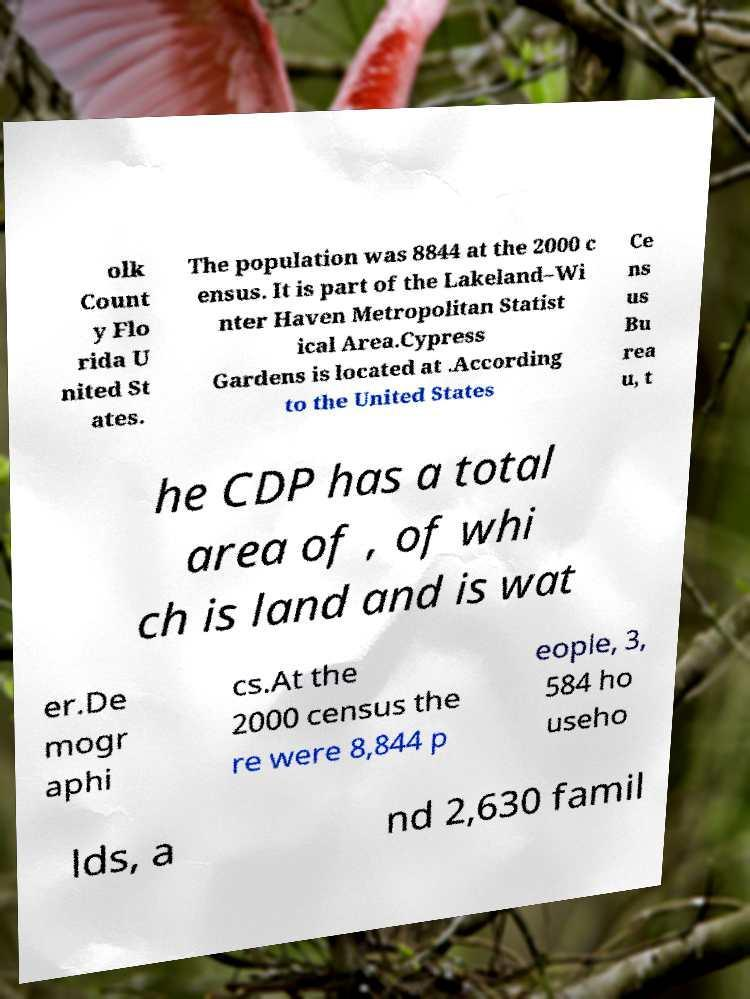Please identify and transcribe the text found in this image. olk Count y Flo rida U nited St ates. The population was 8844 at the 2000 c ensus. It is part of the Lakeland–Wi nter Haven Metropolitan Statist ical Area.Cypress Gardens is located at .According to the United States Ce ns us Bu rea u, t he CDP has a total area of , of whi ch is land and is wat er.De mogr aphi cs.At the 2000 census the re were 8,844 p eople, 3, 584 ho useho lds, a nd 2,630 famil 